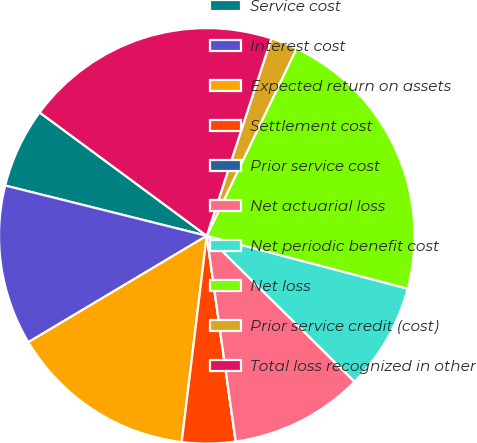<chart> <loc_0><loc_0><loc_500><loc_500><pie_chart><fcel>Service cost<fcel>Interest cost<fcel>Expected return on assets<fcel>Settlement cost<fcel>Prior service cost<fcel>Net actuarial loss<fcel>Net periodic benefit cost<fcel>Net loss<fcel>Prior service credit (cost)<fcel>Total loss recognized in other<nl><fcel>6.23%<fcel>12.45%<fcel>14.52%<fcel>4.15%<fcel>0.0%<fcel>10.38%<fcel>8.3%<fcel>21.98%<fcel>2.08%<fcel>19.91%<nl></chart> 